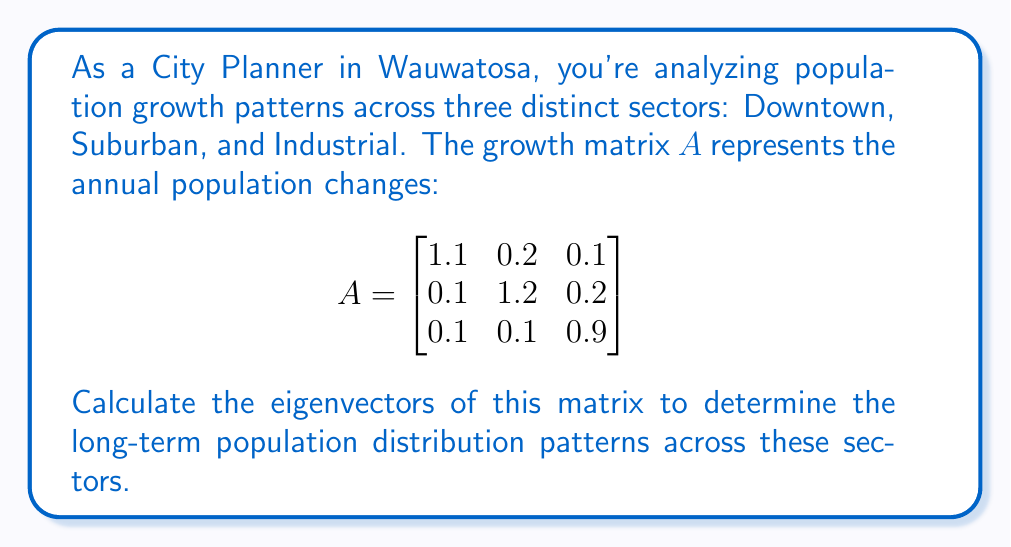Could you help me with this problem? To find the eigenvectors, we follow these steps:

1) First, we need to find the eigenvalues by solving the characteristic equation:
   $\det(A - \lambda I) = 0$

2) Expand the determinant:
   $$\begin{vmatrix}
   1.1-\lambda & 0.2 & 0.1 \\
   0.1 & 1.2-\lambda & 0.2 \\
   0.1 & 0.1 & 0.9-\lambda
   \end{vmatrix} = 0$$

3) This gives us the characteristic polynomial:
   $(1.1-\lambda)(1.2-\lambda)(0.9-\lambda) - 0.2(0.1)(0.9-\lambda) - 0.1(0.1)(1.2-\lambda) = 0$

4) Solving this equation (which can be done using a calculator or computer algebra system), we get the eigenvalues:
   $\lambda_1 = 1.4$, $\lambda_2 = 1$, $\lambda_3 = 0.8$

5) Now, for each eigenvalue, we solve $(A - \lambda I)v = 0$ to find the corresponding eigenvector.

6) For $\lambda_1 = 1.4$:
   $$\begin{bmatrix}
   -0.3 & 0.2 & 0.1 \\
   0.1 & -0.2 & 0.2 \\
   0.1 & 0.1 & -0.5
   \end{bmatrix} \begin{bmatrix} v_1 \\ v_2 \\ v_3 \end{bmatrix} = \begin{bmatrix} 0 \\ 0 \\ 0 \end{bmatrix}$$

   Solving this system gives us: $v_1 = 2$, $v_2 = 3$, $v_3 = 1$

7) For $\lambda_2 = 1$:
   $$\begin{bmatrix}
   0.1 & 0.2 & 0.1 \\
   0.1 & 0.2 & 0.2 \\
   0.1 & 0.1 & -0.1
   \end{bmatrix} \begin{bmatrix} v_1 \\ v_2 \\ v_3 \end{bmatrix} = \begin{bmatrix} 0 \\ 0 \\ 0 \end{bmatrix}$$

   Solving this system gives us: $v_1 = 1$, $v_2 = -1$, $v_3 = 0$

8) For $\lambda_3 = 0.8$:
   $$\begin{bmatrix}
   0.3 & 0.2 & 0.1 \\
   0.1 & 0.4 & 0.2 \\
   0.1 & 0.1 & 0.1
   \end{bmatrix} \begin{bmatrix} v_1 \\ v_2 \\ v_3 \end{bmatrix} = \begin{bmatrix} 0 \\ 0 \\ 0 \end{bmatrix}$$

   Solving this system gives us: $v_1 = 1$, $v_2 = 1$, $v_3 = -3$

9) Normalizing these vectors, we get our final eigenvectors.
Answer: The normalized eigenvectors are:

$v_1 = \frac{1}{\sqrt{14}}(2, 3, 1)^T$ corresponding to $\lambda_1 = 1.4$

$v_2 = \frac{1}{\sqrt{2}}(1, -1, 0)^T$ corresponding to $\lambda_2 = 1$

$v_3 = \frac{1}{\sqrt{11}}(1, 1, -3)^T$ corresponding to $\lambda_3 = 0.8$ 